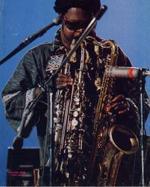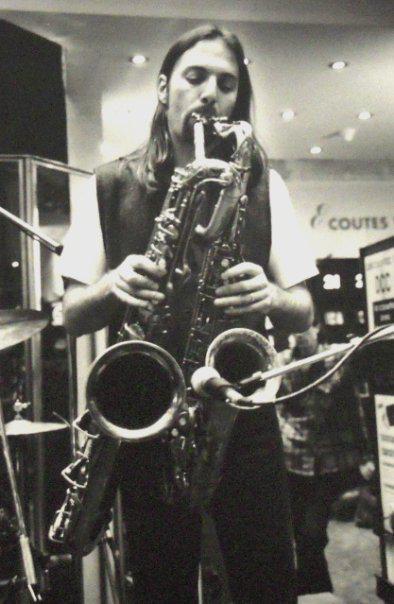The first image is the image on the left, the second image is the image on the right. Examine the images to the left and right. Is the description "Two men, each playing at least two saxophones simultaneously, are the sole people playing musical instruments in the images." accurate? Answer yes or no. Yes. The first image is the image on the left, the second image is the image on the right. Evaluate the accuracy of this statement regarding the images: "The right image contains a man in dark sunglasses holding two saxophones.". Is it true? Answer yes or no. No. 